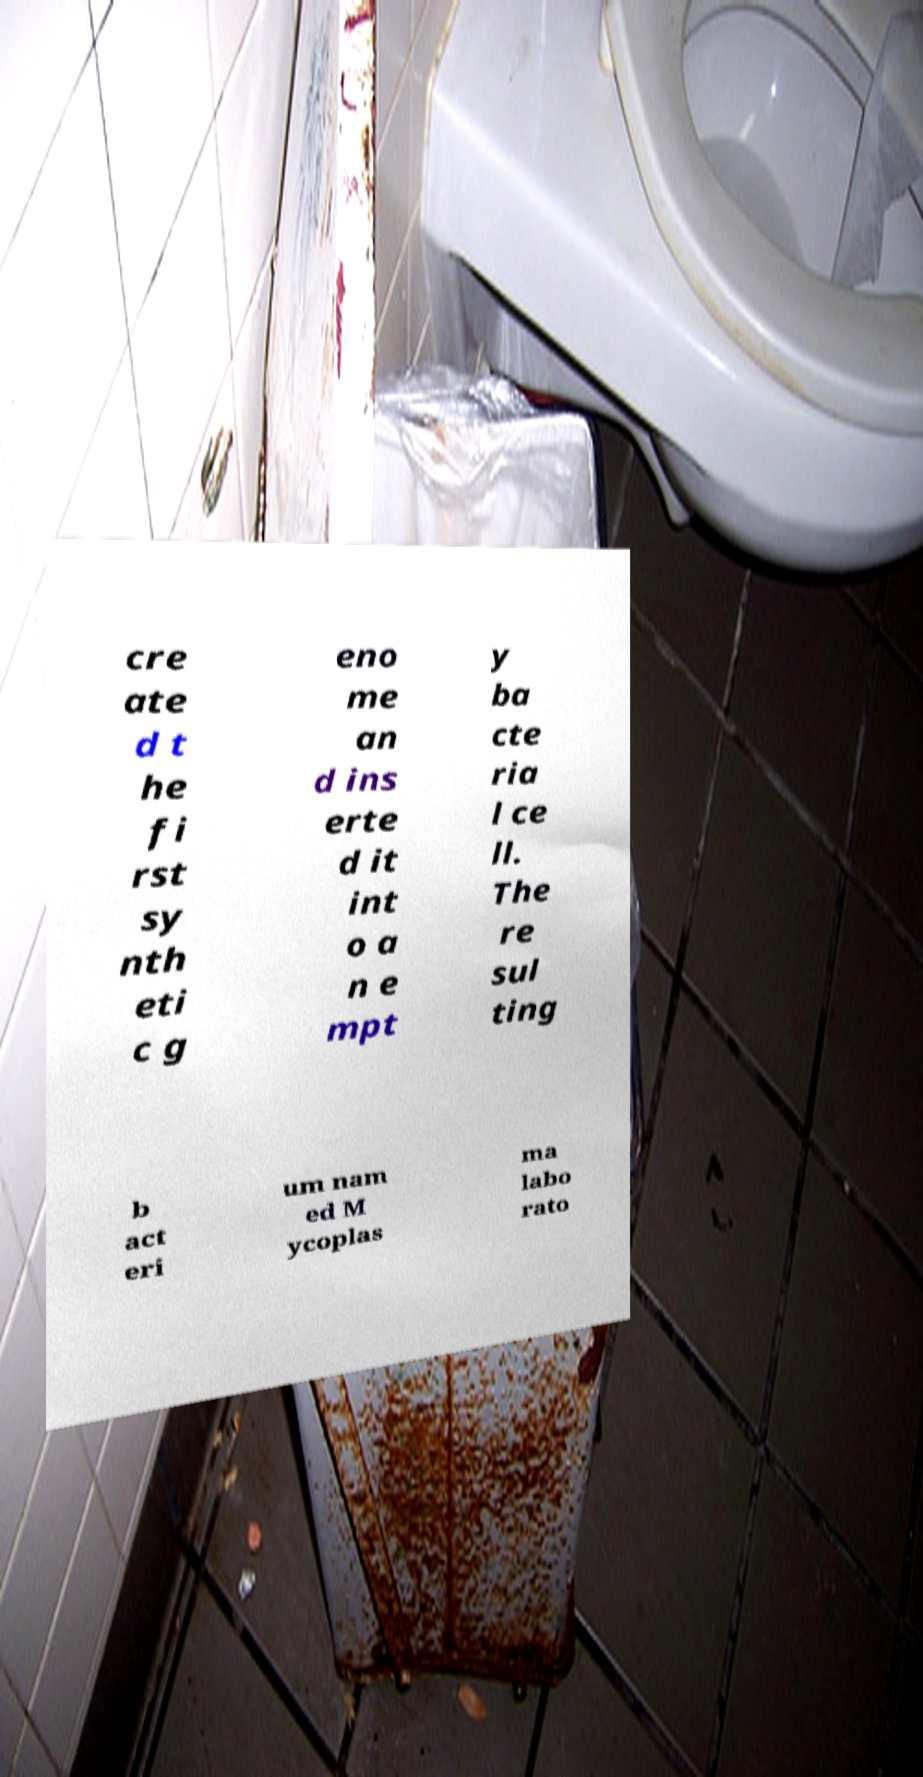For documentation purposes, I need the text within this image transcribed. Could you provide that? cre ate d t he fi rst sy nth eti c g eno me an d ins erte d it int o a n e mpt y ba cte ria l ce ll. The re sul ting b act eri um nam ed M ycoplas ma labo rato 